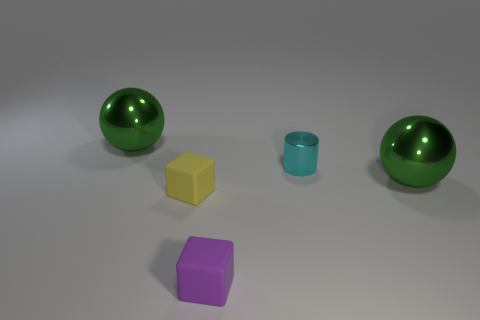Add 5 purple rubber blocks. How many objects exist? 10 Subtract all purple blocks. How many blocks are left? 1 Subtract all cylinders. How many objects are left? 4 Subtract all small yellow matte things. Subtract all big balls. How many objects are left? 2 Add 1 small cyan cylinders. How many small cyan cylinders are left? 2 Add 4 small yellow cubes. How many small yellow cubes exist? 5 Subtract 1 cyan cylinders. How many objects are left? 4 Subtract all cyan balls. Subtract all green cylinders. How many balls are left? 2 